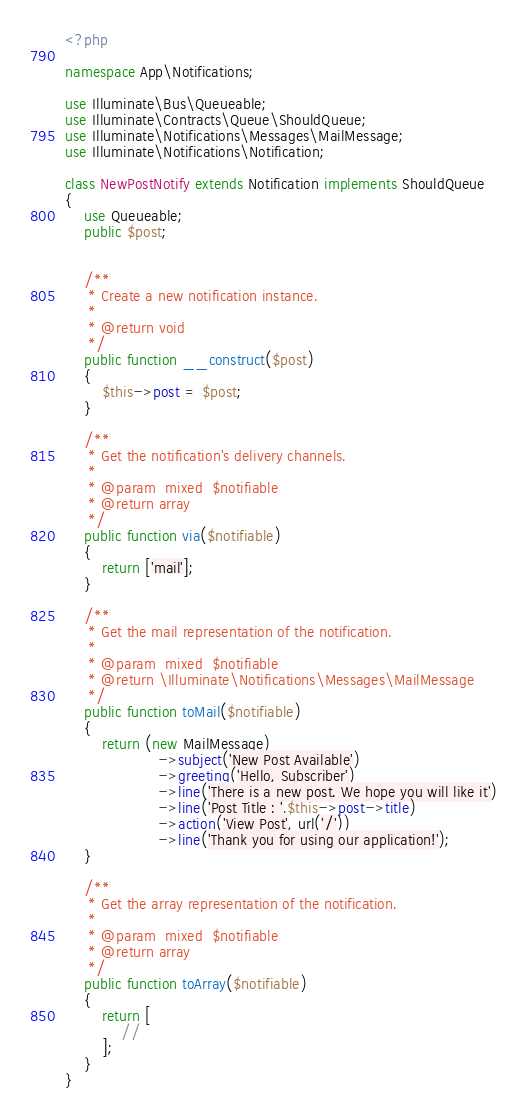<code> <loc_0><loc_0><loc_500><loc_500><_PHP_><?php

namespace App\Notifications;

use Illuminate\Bus\Queueable;
use Illuminate\Contracts\Queue\ShouldQueue;
use Illuminate\Notifications\Messages\MailMessage;
use Illuminate\Notifications\Notification;

class NewPostNotify extends Notification implements ShouldQueue
{
    use Queueable;
    public $post;


    /**
     * Create a new notification instance.
     *
     * @return void
     */
    public function __construct($post)
    {
        $this->post = $post;
    }

    /**
     * Get the notification's delivery channels.
     *
     * @param  mixed  $notifiable
     * @return array
     */
    public function via($notifiable)
    {
        return ['mail'];
    }

    /**
     * Get the mail representation of the notification.
     *
     * @param  mixed  $notifiable
     * @return \Illuminate\Notifications\Messages\MailMessage
     */
    public function toMail($notifiable)
    {
        return (new MailMessage)
                    ->subject('New Post Available')
                    ->greeting('Hello, Subscriber')
                    ->line('There is a new post. We hope you will like it')
                    ->line('Post Title : '.$this->post->title)
                    ->action('View Post', url('/'))
                    ->line('Thank you for using our application!');
    }

    /**
     * Get the array representation of the notification.
     *
     * @param  mixed  $notifiable
     * @return array
     */
    public function toArray($notifiable)
    {
        return [
            //
        ];
    }
}
</code> 